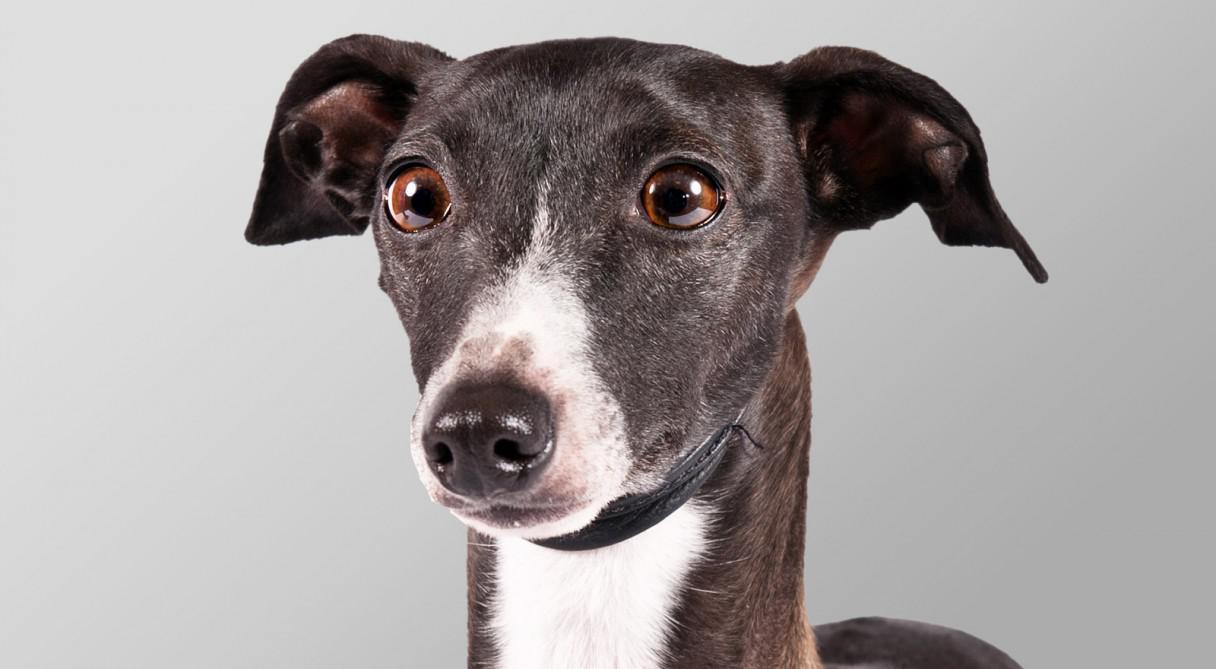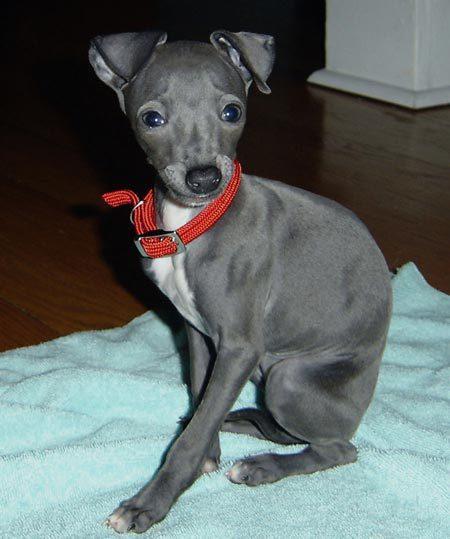The first image is the image on the left, the second image is the image on the right. Considering the images on both sides, is "Left image contains more than one dog, with at least one wearing a collar." valid? Answer yes or no. No. The first image is the image on the left, the second image is the image on the right. Evaluate the accuracy of this statement regarding the images: "A dog is sitting on a cloth.". Is it true? Answer yes or no. Yes. 